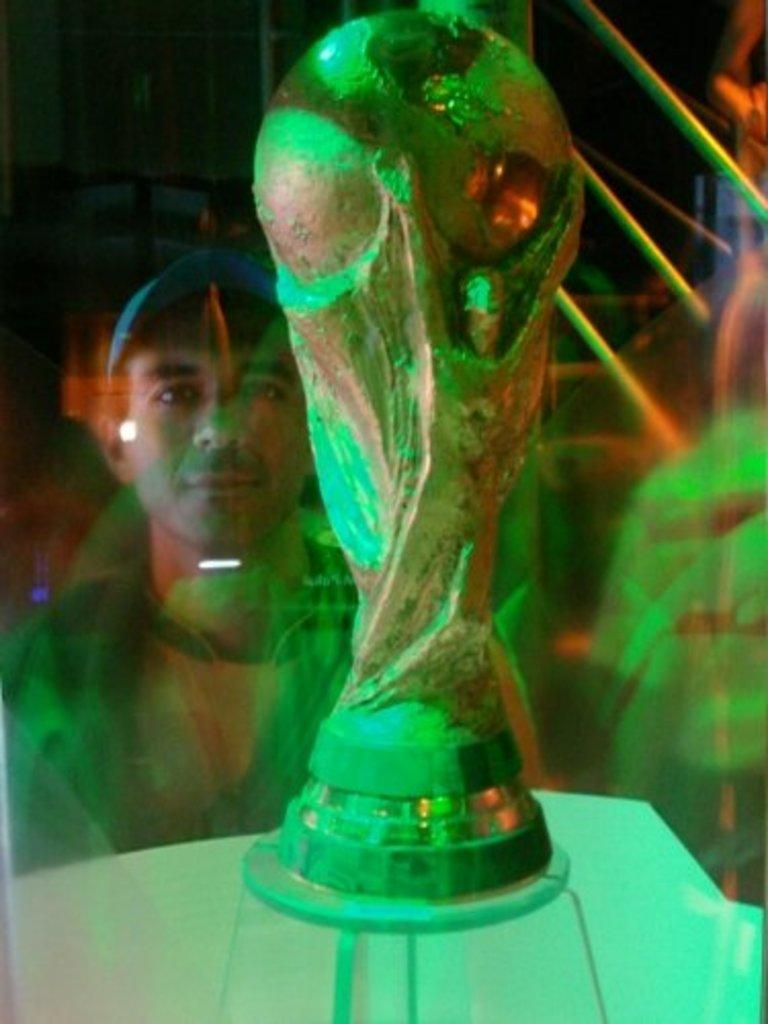What is the main subject of the image? The main subject of the image is a football cup on a podium. Can you describe the person in the image? There is a person watching behind the cup. What can be observed about the background of the image? The background of the image is blurred. What type of credit card is visible in the image? There is no credit card present in the image. Is the football cup floating in space in the image? No, the football cup is on a podium, and there is no indication of a space setting in the image. 